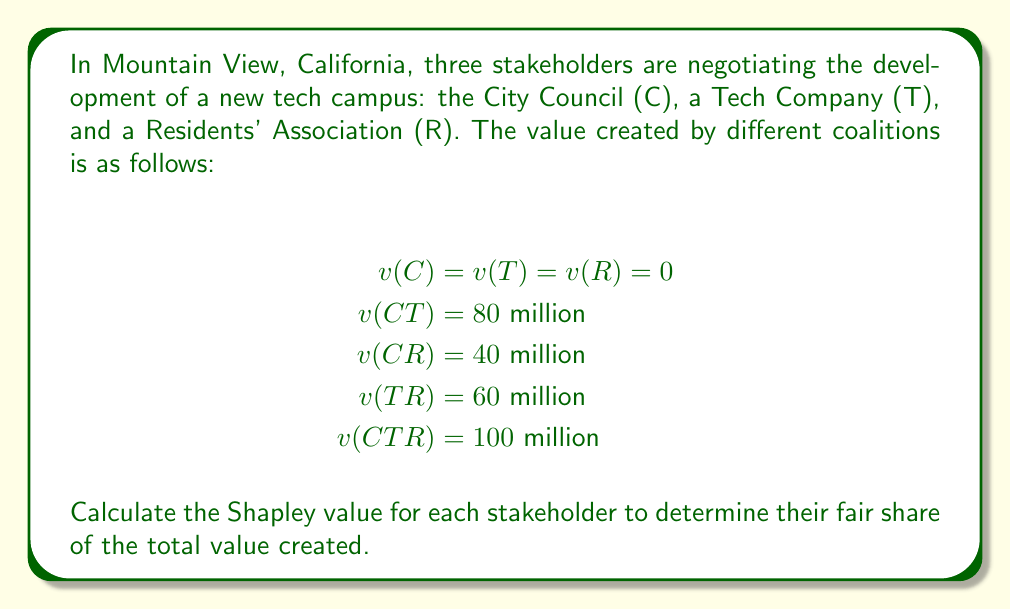Could you help me with this problem? To calculate the Shapley value for each stakeholder, we need to determine their marginal contributions in all possible orderings and then take the average.

There are 3! = 6 possible orderings of the stakeholders:

1. C, T, R
2. C, R, T
3. T, C, R
4. T, R, C
5. R, C, T
6. R, T, C

Let's calculate the marginal contribution of each stakeholder in each ordering:

1. C, T, R:
   C: 0, T: 80, R: 20

2. C, R, T:
   C: 0, R: 40, T: 60

3. T, C, R:
   T: 0, C: 80, R: 20

4. T, R, C:
   T: 0, R: 60, C: 40

5. R, C, T:
   R: 0, C: 40, T: 60

6. R, T, C:
   R: 0, T: 60, C: 40

Now, we sum up the marginal contributions for each stakeholder and divide by 6 to get their Shapley value:

City Council (C):
$\phi_C = \frac{0 + 0 + 80 + 40 + 40 + 40}{6} = \frac{200}{6} = \frac{100}{3}$

Tech Company (T):
$\phi_T = \frac{80 + 60 + 0 + 0 + 60 + 60}{6} = \frac{260}{6} = \frac{130}{3}$

Residents' Association (R):
$\phi_R = \frac{20 + 40 + 20 + 60 + 0 + 0}{6} = \frac{140}{6} = \frac{70}{3}$

We can verify that the sum of Shapley values equals the total value created:

$\phi_C + \phi_T + \phi_R = \frac{100}{3} + \frac{130}{3} + \frac{70}{3} = \frac{300}{3} = 100$

This matches the value of the grand coalition $v(CTR) = 100$ million.
Answer: The Shapley values for each stakeholder are:

City Council (C): $\frac{100}{3}$ million ≈ $33.33$ million
Tech Company (T): $\frac{130}{3}$ million ≈ $43.33$ million
Residents' Association (R): $\frac{70}{3}$ million ≈ $23.33$ million 